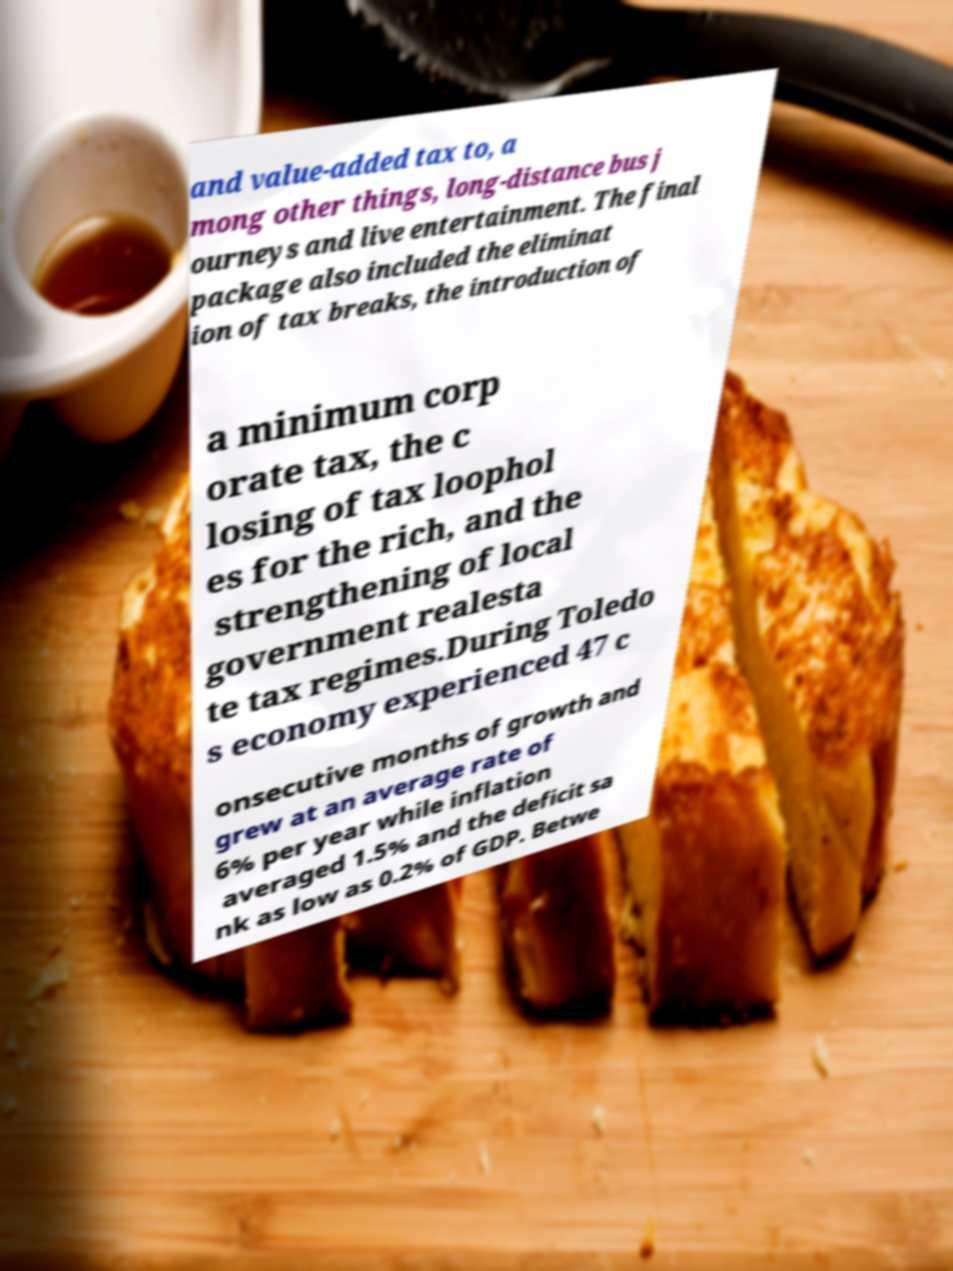Please identify and transcribe the text found in this image. and value-added tax to, a mong other things, long-distance bus j ourneys and live entertainment. The final package also included the eliminat ion of tax breaks, the introduction of a minimum corp orate tax, the c losing of tax loophol es for the rich, and the strengthening of local government realesta te tax regimes.During Toledo s economy experienced 47 c onsecutive months of growth and grew at an average rate of 6% per year while inflation averaged 1.5% and the deficit sa nk as low as 0.2% of GDP. Betwe 